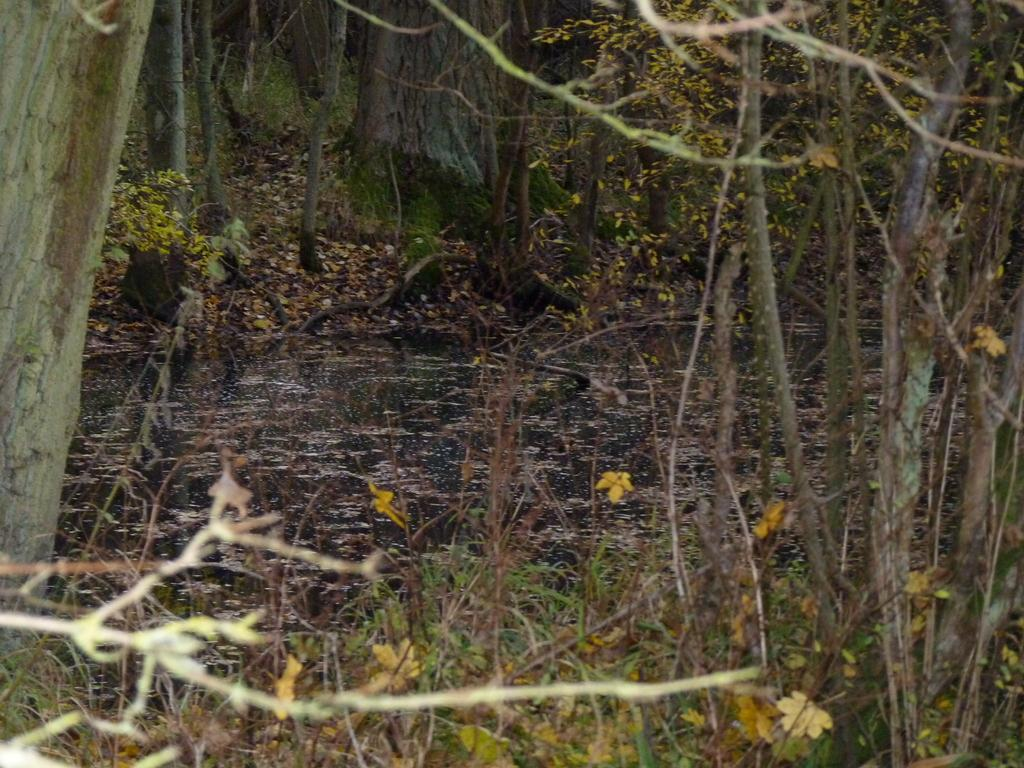What type of vegetation can be seen in the image? There are trees and plants in the image. What is located in the middle of the image? There is water in the middle of the image. What type of machine can be seen operating in the water in the image? There is no machine present in the image; it only features trees, plants, and water. How many eggs are visible in the image? There are no eggs present in the image. 